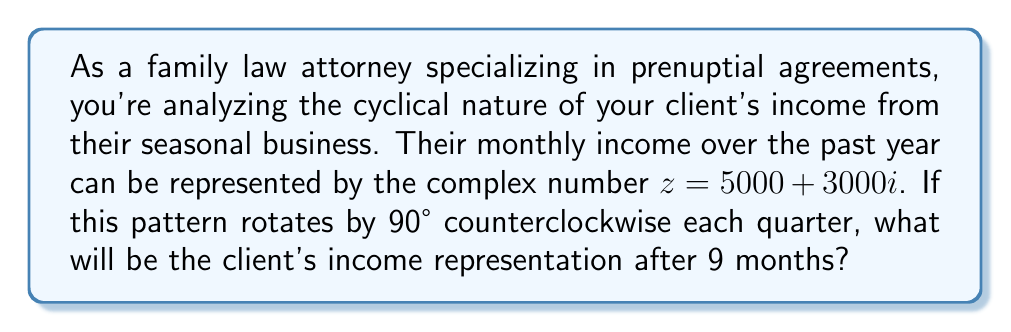Solve this math problem. Let's approach this step-by-step:

1) The initial income is represented by $z = 5000 + 3000i$.

2) A 90° counterclockwise rotation is equivalent to multiplying by $i$. This is because:
   $i = \cos(90°) + i\sin(90°) = e^{i\pi/2}$

3) After 3 months (one quarter), the income will be:
   $z_1 = zi = (5000 + 3000i)i = -3000 + 5000i$

4) After 6 months (two quarters), the income will be:
   $z_2 = z_1i = (-3000 + 5000i)i = -5000 - 3000i$

5) After 9 months (three quarters), the income will be:
   $z_3 = z_2i = (-5000 - 3000i)i = 3000 - 5000i$

6) We can verify this by noting that a 270° counterclockwise rotation is equivalent to multiplying by $i^3$:
   $z_3 = zi^3 = (5000 + 3000i)(-i) = 3000 - 5000i$

Therefore, after 9 months, the client's income will be represented by $3000 - 5000i$.
Answer: $3000 - 5000i$ 